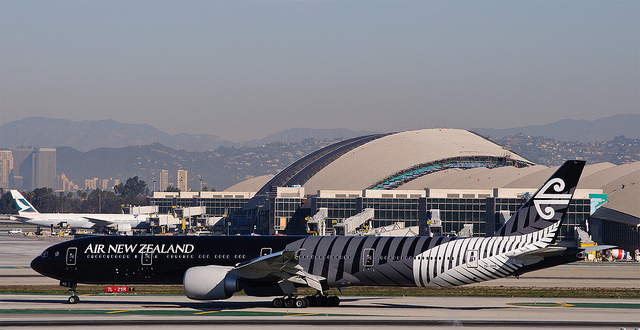Identify the text contained in this image. AIR NEW ZEALAND 